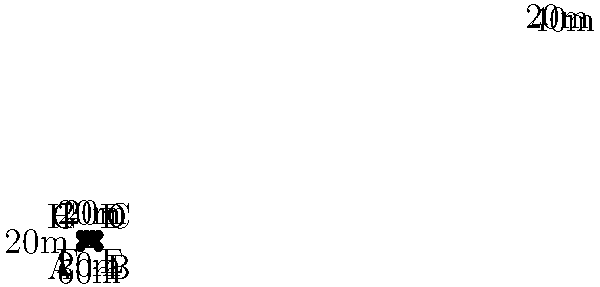As a project manager overseeing a construction project, you're tasked with calculating the perimeter of an irregularly shaped construction site. The site's dimensions are shown in the diagram above. What is the total perimeter of the construction site in meters? To calculate the perimeter, we need to sum up all the sides of the irregular shape:

1. Side AB: 60m
2. Side BC: 40m
3. Side CD: 20m
4. Side DE: 20m
5. Side EF: 20m
6. Side FG: 20m
7. Side GH: 20m
8. Side HA: 40m

Let's add all these lengths:

$$\text{Perimeter} = 60 + 40 + 20 + 20 + 20 + 20 + 20 + 40 = 240$$

Therefore, the total perimeter of the construction site is 240 meters.
Answer: 240 meters 